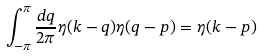<formula> <loc_0><loc_0><loc_500><loc_500>\int _ { - \pi } ^ { \pi } \frac { d q } { 2 \pi } \eta ( k - q ) \eta ( q - p ) = \eta ( k - p )</formula> 